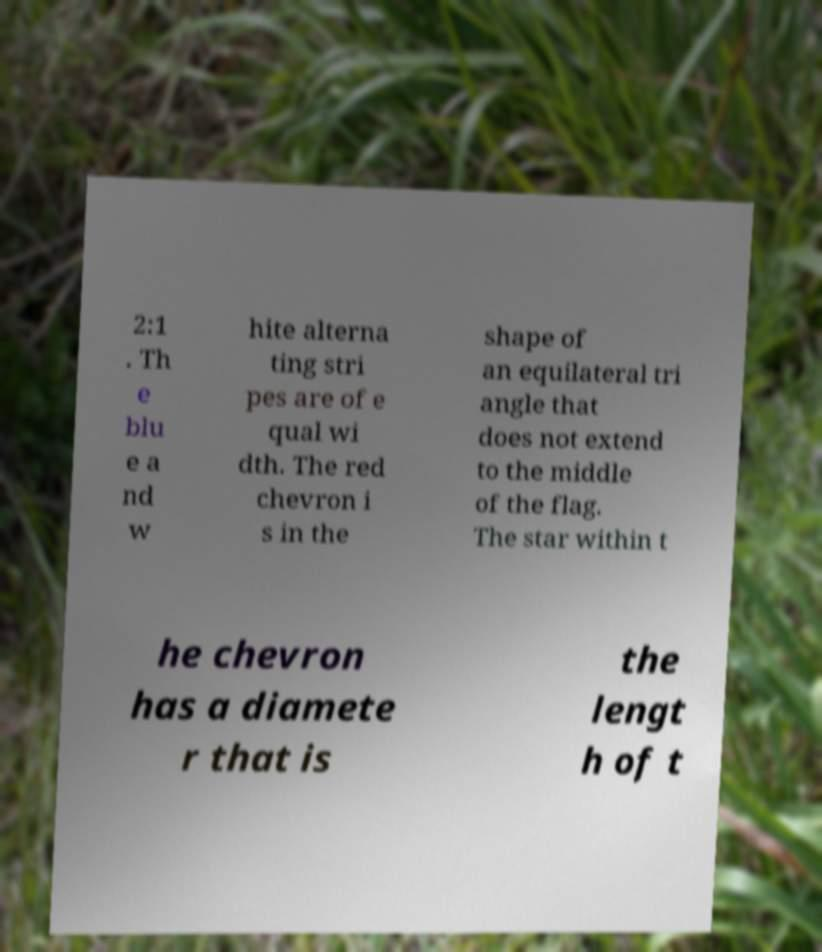I need the written content from this picture converted into text. Can you do that? 2:1 . Th e blu e a nd w hite alterna ting stri pes are of e qual wi dth. The red chevron i s in the shape of an equilateral tri angle that does not extend to the middle of the flag. The star within t he chevron has a diamete r that is the lengt h of t 